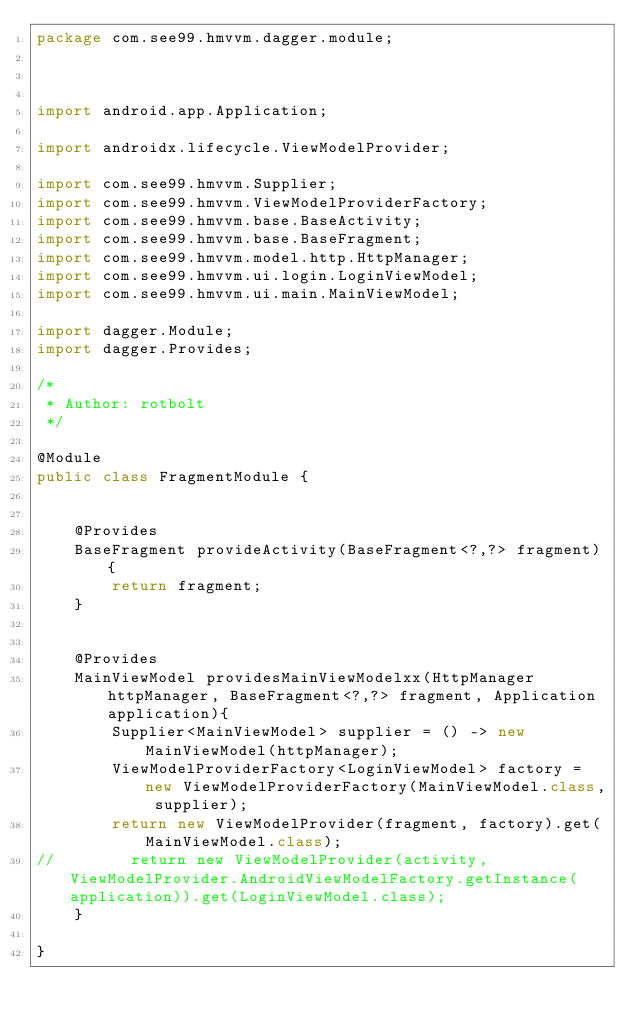Convert code to text. <code><loc_0><loc_0><loc_500><loc_500><_Java_>package com.see99.hmvvm.dagger.module;



import android.app.Application;

import androidx.lifecycle.ViewModelProvider;

import com.see99.hmvvm.Supplier;
import com.see99.hmvvm.ViewModelProviderFactory;
import com.see99.hmvvm.base.BaseActivity;
import com.see99.hmvvm.base.BaseFragment;
import com.see99.hmvvm.model.http.HttpManager;
import com.see99.hmvvm.ui.login.LoginViewModel;
import com.see99.hmvvm.ui.main.MainViewModel;

import dagger.Module;
import dagger.Provides;

/*
 * Author: rotbolt
 */

@Module
public class FragmentModule {


    @Provides
    BaseFragment provideActivity(BaseFragment<?,?> fragment){
        return fragment;
    }


    @Provides
    MainViewModel providesMainViewModelxx(HttpManager httpManager, BaseFragment<?,?> fragment, Application application){
        Supplier<MainViewModel> supplier = () -> new MainViewModel(httpManager);
        ViewModelProviderFactory<LoginViewModel> factory = new ViewModelProviderFactory(MainViewModel.class, supplier);
        return new ViewModelProvider(fragment, factory).get(MainViewModel.class);
//        return new ViewModelProvider(activity,ViewModelProvider.AndroidViewModelFactory.getInstance(application)).get(LoginViewModel.class);
    }

}
</code> 